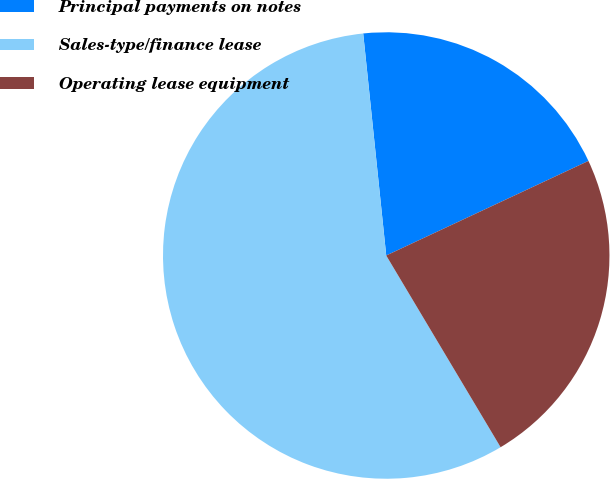Convert chart. <chart><loc_0><loc_0><loc_500><loc_500><pie_chart><fcel>Principal payments on notes<fcel>Sales-type/finance lease<fcel>Operating lease equipment<nl><fcel>19.68%<fcel>56.91%<fcel>23.4%<nl></chart> 